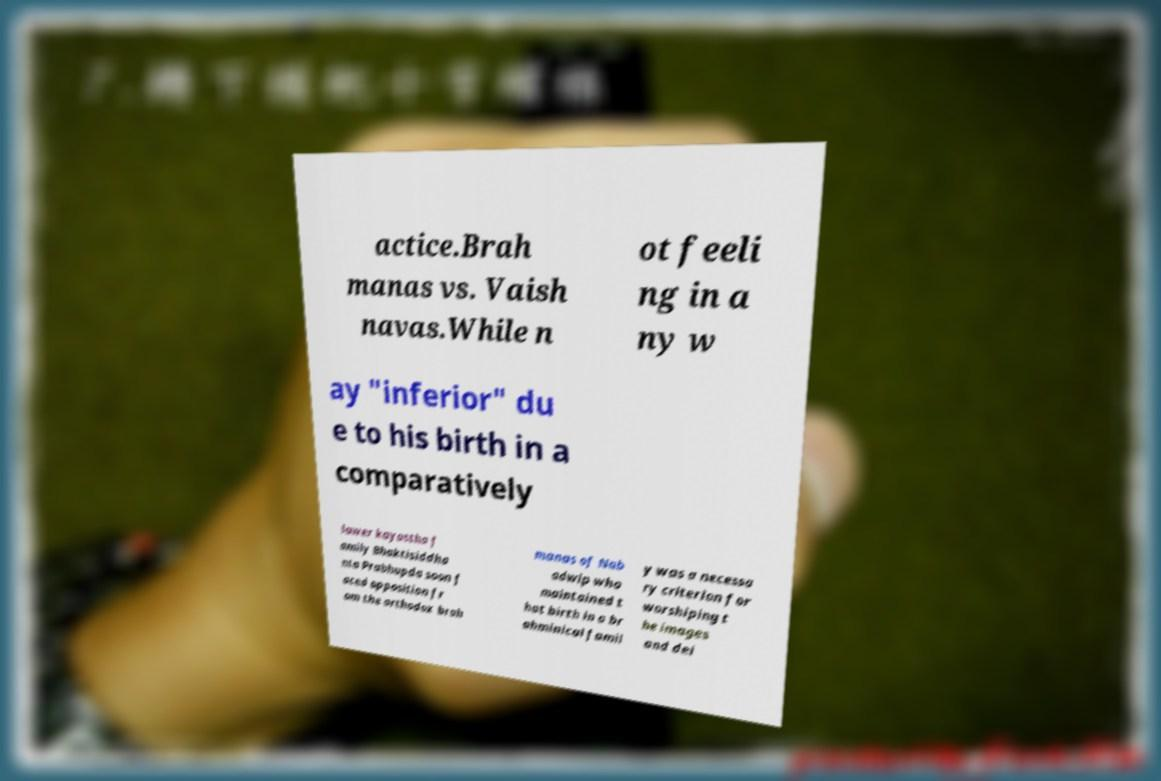Could you extract and type out the text from this image? actice.Brah manas vs. Vaish navas.While n ot feeli ng in a ny w ay "inferior" du e to his birth in a comparatively lower kayastha f amily Bhaktisiddha nta Prabhupda soon f aced opposition fr om the orthodox brah manas of Nab adwip who maintained t hat birth in a br ahminical famil y was a necessa ry criterion for worshiping t he images and dei 